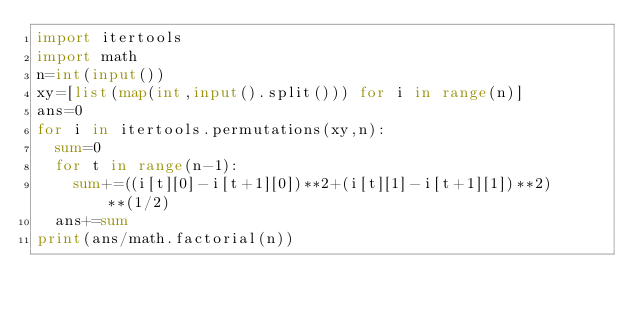Convert code to text. <code><loc_0><loc_0><loc_500><loc_500><_Python_>import itertools
import math
n=int(input())
xy=[list(map(int,input().split())) for i in range(n)]
ans=0
for i in itertools.permutations(xy,n):
  sum=0
  for t in range(n-1):
    sum+=((i[t][0]-i[t+1][0])**2+(i[t][1]-i[t+1][1])**2)**(1/2)
  ans+=sum
print(ans/math.factorial(n))
  </code> 